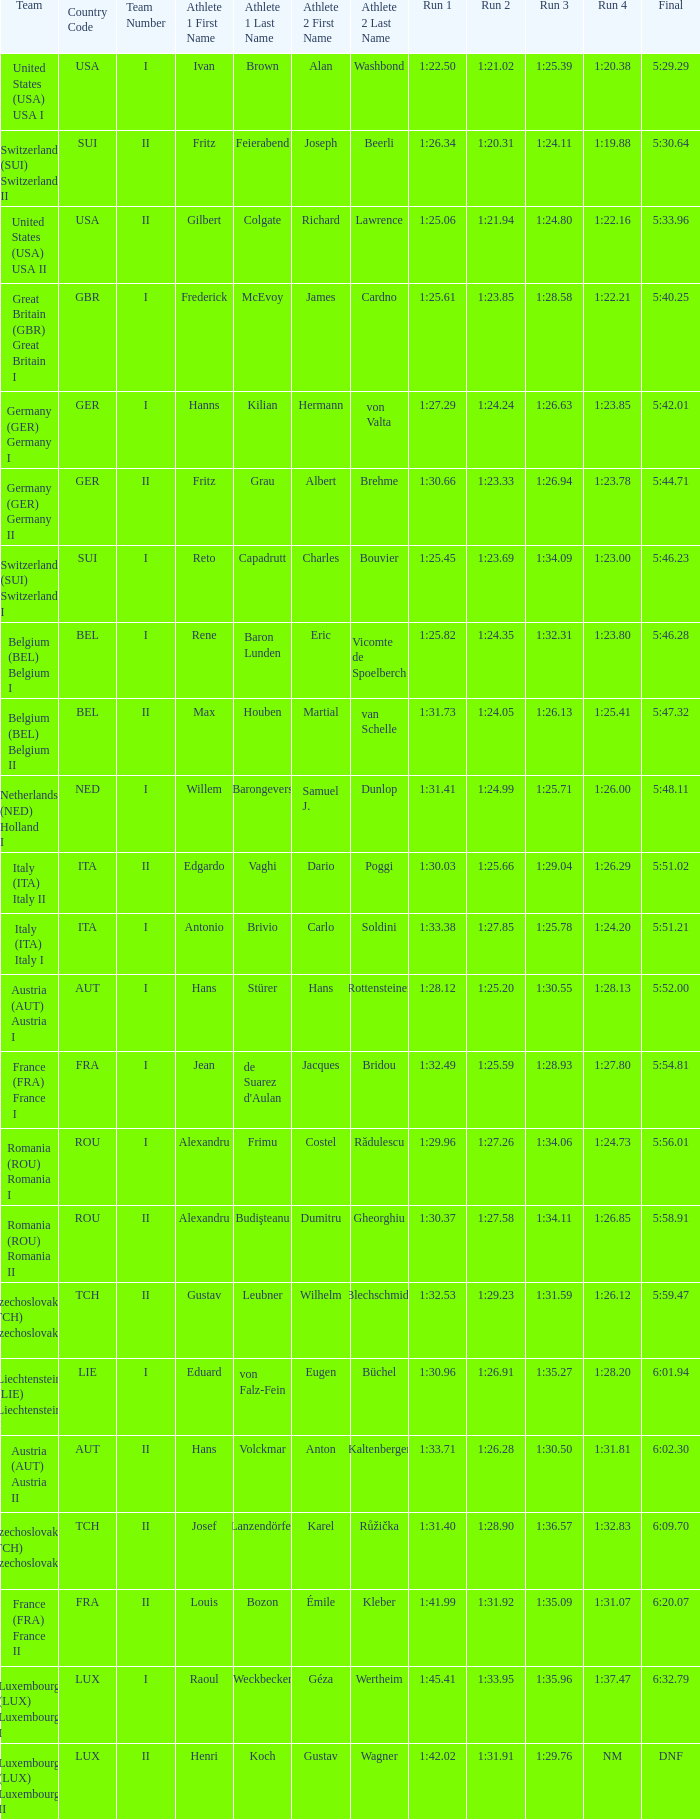Which run 4 possesses a run 3 duration of 1:2 1:23.85. Could you help me parse every detail presented in this table? {'header': ['Team', 'Country Code', 'Team Number', 'Athlete 1 First Name', 'Athlete 1 Last Name', 'Athlete 2 First Name', 'Athlete 2 Last Name', 'Run 1', 'Run 2', 'Run 3', 'Run 4', 'Final'], 'rows': [['United States (USA) USA I', 'USA', 'I', 'Ivan', 'Brown', 'Alan', 'Washbond', '1:22.50', '1:21.02', '1:25.39', '1:20.38', '5:29.29'], ['Switzerland (SUI) Switzerland II', 'SUI', 'II', 'Fritz', 'Feierabend', 'Joseph', 'Beerli', '1:26.34', '1:20.31', '1:24.11', '1:19.88', '5:30.64'], ['United States (USA) USA II', 'USA', 'II', 'Gilbert', 'Colgate', 'Richard', 'Lawrence', '1:25.06', '1:21.94', '1:24.80', '1:22.16', '5:33.96'], ['Great Britain (GBR) Great Britain I', 'GBR', 'I', 'Frederick', 'McEvoy', 'James', 'Cardno', '1:25.61', '1:23.85', '1:28.58', '1:22.21', '5:40.25'], ['Germany (GER) Germany I', 'GER', 'I', 'Hanns', 'Kilian', 'Hermann', 'von Valta', '1:27.29', '1:24.24', '1:26.63', '1:23.85', '5:42.01'], ['Germany (GER) Germany II', 'GER', 'II', 'Fritz', 'Grau', 'Albert', 'Brehme', '1:30.66', '1:23.33', '1:26.94', '1:23.78', '5:44.71'], ['Switzerland (SUI) Switzerland I', 'SUI', 'I', 'Reto', 'Capadrutt', 'Charles', 'Bouvier', '1:25.45', '1:23.69', '1:34.09', '1:23.00', '5:46.23'], ['Belgium (BEL) Belgium I', 'BEL', 'I', 'Rene', 'Baron Lunden', 'Eric', 'Vicomte de Spoelberch', '1:25.82', '1:24.35', '1:32.31', '1:23.80', '5:46.28'], ['Belgium (BEL) Belgium II', 'BEL', 'II', 'Max', 'Houben', 'Martial', 'van Schelle', '1:31.73', '1:24.05', '1:26.13', '1:25.41', '5:47.32'], ['Netherlands (NED) Holland I', 'NED', 'I', 'Willem', 'Barongevers', 'Samuel J.', 'Dunlop', '1:31.41', '1:24.99', '1:25.71', '1:26.00', '5:48.11'], ['Italy (ITA) Italy II', 'ITA', 'II', 'Edgardo', 'Vaghi', 'Dario', 'Poggi', '1:30.03', '1:25.66', '1:29.04', '1:26.29', '5:51.02'], ['Italy (ITA) Italy I', 'ITA', 'I', 'Antonio', 'Brivio', 'Carlo', 'Soldini', '1:33.38', '1:27.85', '1:25.78', '1:24.20', '5:51.21'], ['Austria (AUT) Austria I', 'AUT', 'I', 'Hans', 'Stürer', 'Hans', 'Rottensteiner', '1:28.12', '1:25.20', '1:30.55', '1:28.13', '5:52.00'], ['France (FRA) France I', 'FRA', 'I', 'Jean', "de Suarez d'Aulan", 'Jacques', 'Bridou', '1:32.49', '1:25.59', '1:28.93', '1:27.80', '5:54.81'], ['Romania (ROU) Romania I', 'ROU', 'I', 'Alexandru', 'Frimu', 'Costel', 'Rădulescu', '1:29.96', '1:27.26', '1:34.06', '1:24.73', '5:56.01'], ['Romania (ROU) Romania II', 'ROU', 'II', 'Alexandru', 'Budişteanu', 'Dumitru', 'Gheorghiu', '1:30.37', '1:27.58', '1:34.11', '1:26.85', '5:58.91'], ['Czechoslovakia (TCH) Czechoslovakia II', 'TCH', 'II', 'Gustav', 'Leubner', 'Wilhelm', 'Blechschmidt', '1:32.53', '1:29.23', '1:31.59', '1:26.12', '5:59.47'], ['Liechtenstein (LIE) Liechtenstein I', 'LIE', 'I', 'Eduard', 'von Falz-Fein', 'Eugen', 'Büchel', '1:30.96', '1:26.91', '1:35.27', '1:28.20', '6:01.94'], ['Austria (AUT) Austria II', 'AUT', 'II', 'Hans', 'Volckmar', 'Anton', 'Kaltenberger', '1:33.71', '1:26.28', '1:30.50', '1:31.81', '6:02.30'], ['Czechoslovakia (TCH) Czechoslovakia II', 'TCH', 'II', 'Josef', 'Lanzendörfer', 'Karel', 'Růžička', '1:31.40', '1:28.90', '1:36.57', '1:32.83', '6:09.70'], ['France (FRA) France II', 'FRA', 'II', 'Louis', 'Bozon', 'Émile', 'Kleber', '1:41.99', '1:31.92', '1:35.09', '1:31.07', '6:20.07'], ['Luxembourg (LUX) Luxembourg I', 'LUX', 'I', 'Raoul', 'Weckbecker', 'Géza', 'Wertheim', '1:45.41', '1:33.95', '1:35.96', '1:37.47', '6:32.79'], ['Luxembourg (LUX) Luxembourg II', 'LUX', 'II', 'Henri', 'Koch', 'Gustav', 'Wagner', '1:42.02', '1:31.91', '1:29.76', 'NM', 'DNF']]} 